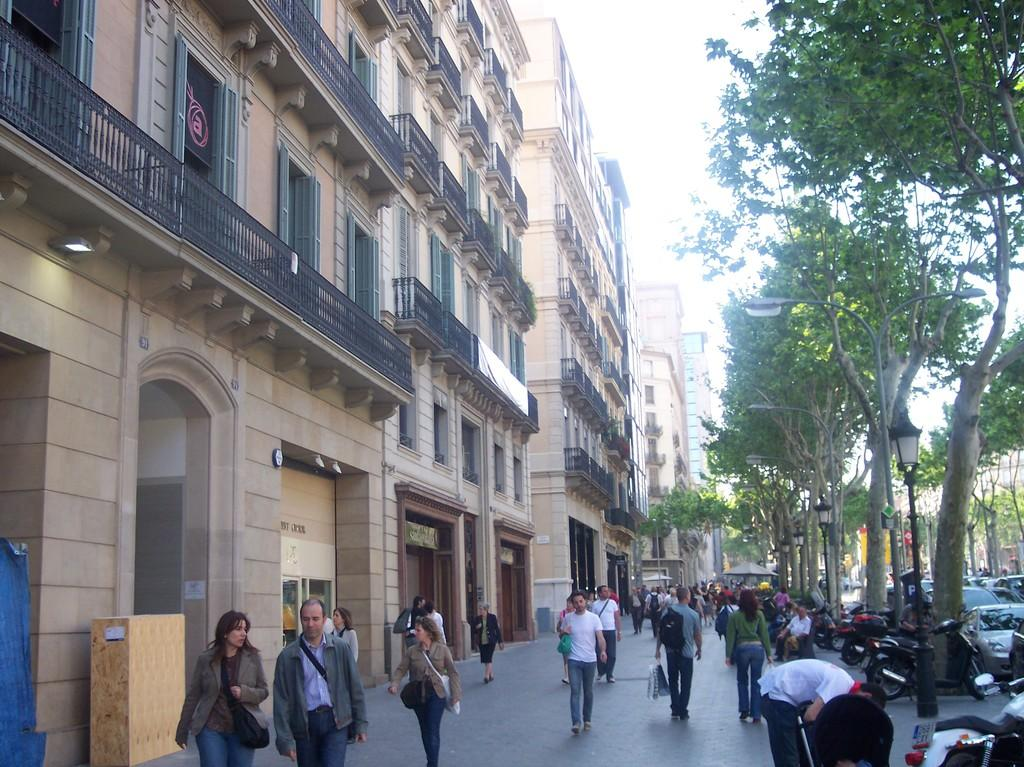What type of structures can be seen in the image? There are buildings in the image. What other natural elements are present in the image? There are trees in the image. What are the lights in the image used for? The lights in the image are likely used for illumination. What are the poles in the image used for? The poles in the image are likely used for supporting the lights or other infrastructure. What are the people in the image doing? People are walking in the image. What type of transportation can be seen in the image? There are vehicles on the road in the image. What can be seen in the background of the image? The sky is visible in the background of the image. How many cards are being played by the people in the image? There are no cards present in the image; people are walking and there are vehicles on the road. What type of wind can be seen in the image? There is no wind visible in the image, and the term "zephyr" refers to a gentle breeze, which cannot be seen. 